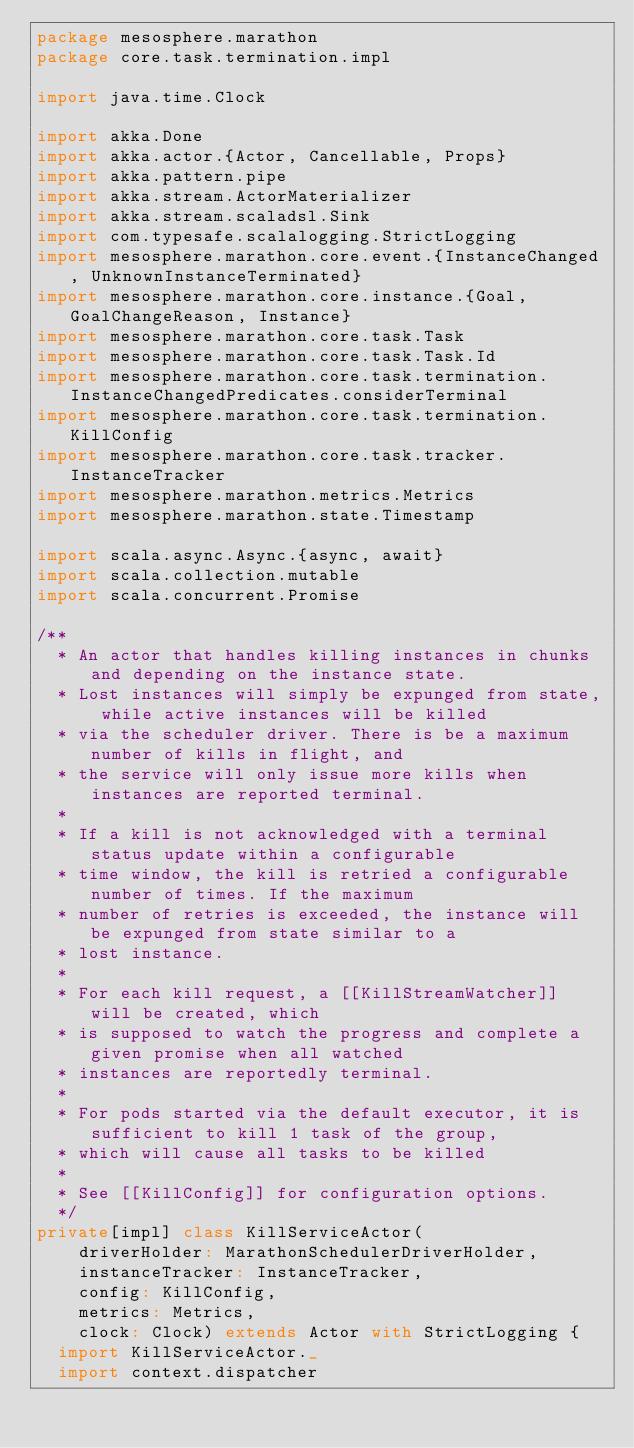<code> <loc_0><loc_0><loc_500><loc_500><_Scala_>package mesosphere.marathon
package core.task.termination.impl

import java.time.Clock

import akka.Done
import akka.actor.{Actor, Cancellable, Props}
import akka.pattern.pipe
import akka.stream.ActorMaterializer
import akka.stream.scaladsl.Sink
import com.typesafe.scalalogging.StrictLogging
import mesosphere.marathon.core.event.{InstanceChanged, UnknownInstanceTerminated}
import mesosphere.marathon.core.instance.{Goal, GoalChangeReason, Instance}
import mesosphere.marathon.core.task.Task
import mesosphere.marathon.core.task.Task.Id
import mesosphere.marathon.core.task.termination.InstanceChangedPredicates.considerTerminal
import mesosphere.marathon.core.task.termination.KillConfig
import mesosphere.marathon.core.task.tracker.InstanceTracker
import mesosphere.marathon.metrics.Metrics
import mesosphere.marathon.state.Timestamp

import scala.async.Async.{async, await}
import scala.collection.mutable
import scala.concurrent.Promise

/**
  * An actor that handles killing instances in chunks and depending on the instance state.
  * Lost instances will simply be expunged from state, while active instances will be killed
  * via the scheduler driver. There is be a maximum number of kills in flight, and
  * the service will only issue more kills when instances are reported terminal.
  *
  * If a kill is not acknowledged with a terminal status update within a configurable
  * time window, the kill is retried a configurable number of times. If the maximum
  * number of retries is exceeded, the instance will be expunged from state similar to a
  * lost instance.
  *
  * For each kill request, a [[KillStreamWatcher]] will be created, which
  * is supposed to watch the progress and complete a given promise when all watched
  * instances are reportedly terminal.
  *
  * For pods started via the default executor, it is sufficient to kill 1 task of the group,
  * which will cause all tasks to be killed
  *
  * See [[KillConfig]] for configuration options.
  */
private[impl] class KillServiceActor(
    driverHolder: MarathonSchedulerDriverHolder,
    instanceTracker: InstanceTracker,
    config: KillConfig,
    metrics: Metrics,
    clock: Clock) extends Actor with StrictLogging {
  import KillServiceActor._
  import context.dispatcher
</code> 